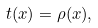<formula> <loc_0><loc_0><loc_500><loc_500>t ( x ) = \rho ( x ) ,</formula> 